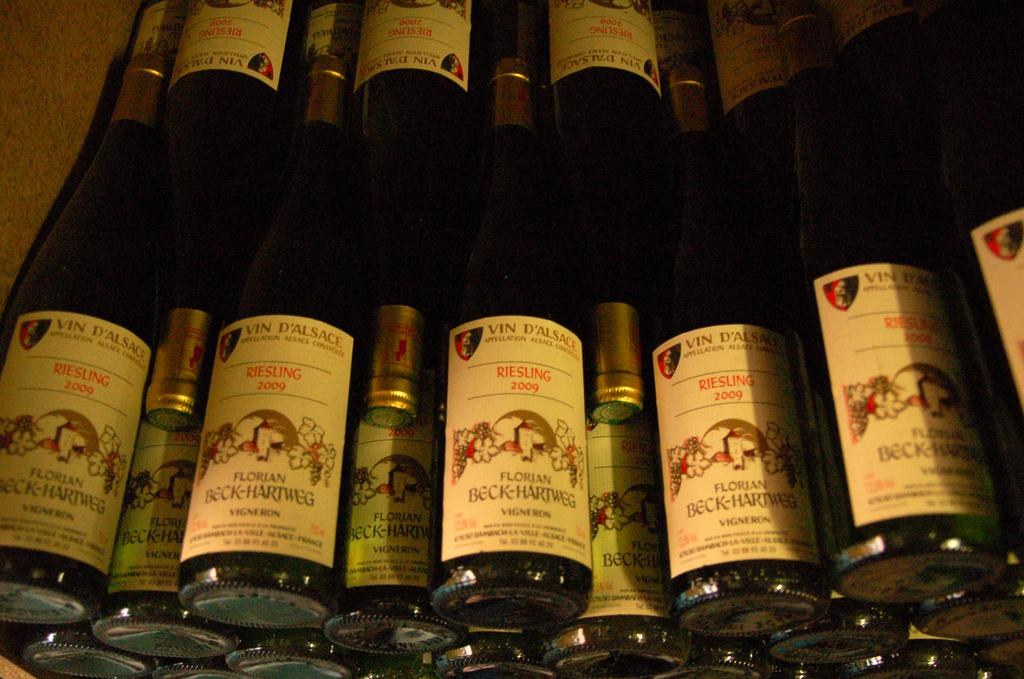<image>
Describe the image concisely. the word Riesling that is on the wine bottle 